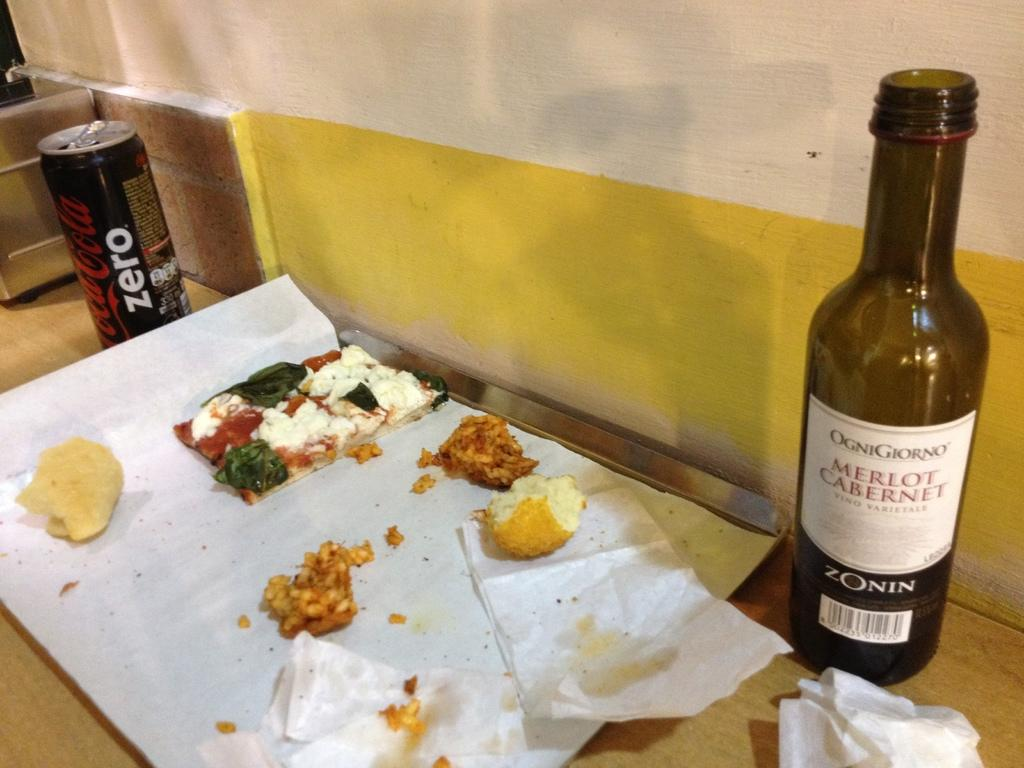<image>
Create a compact narrative representing the image presented. a wine bottle that says merlot caberet on it 